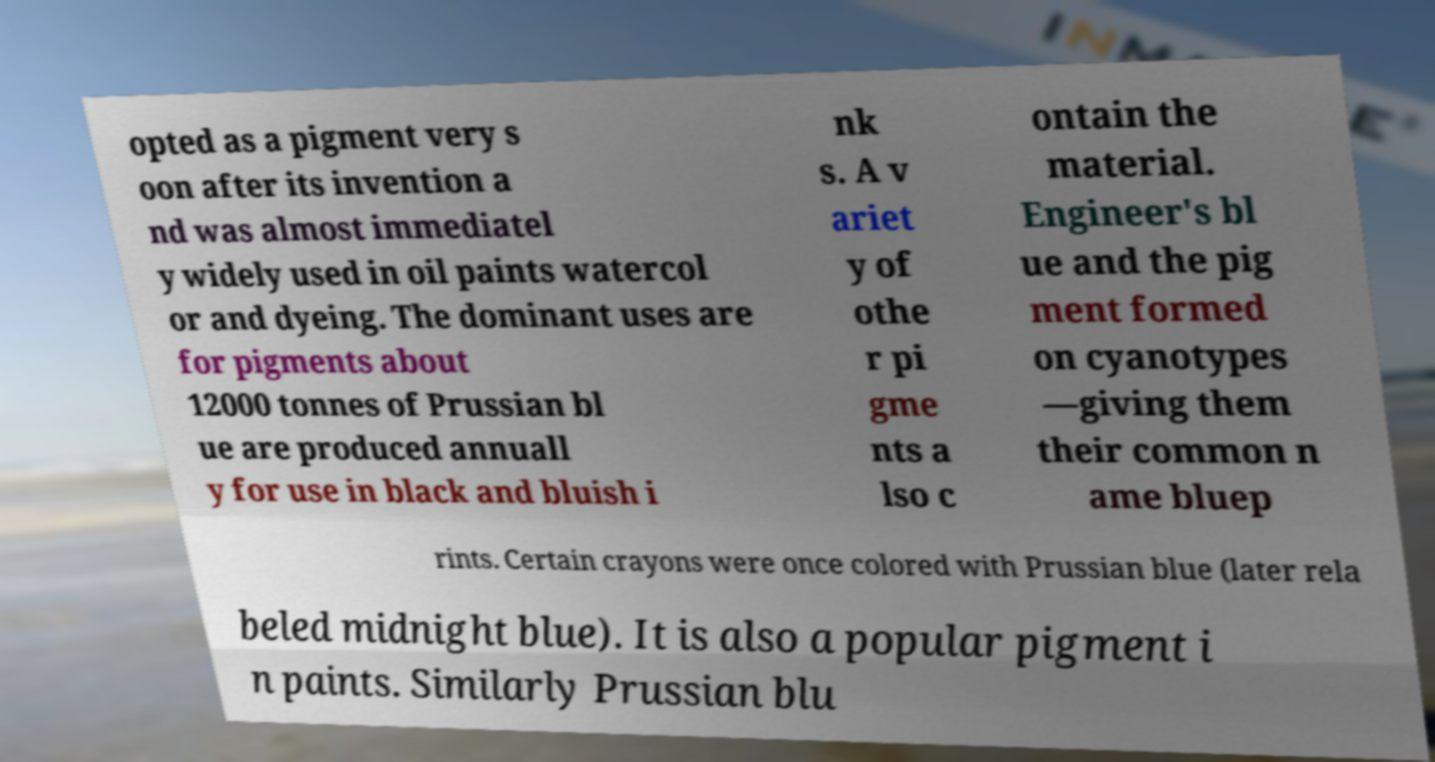Please read and relay the text visible in this image. What does it say? opted as a pigment very s oon after its invention a nd was almost immediatel y widely used in oil paints watercol or and dyeing. The dominant uses are for pigments about 12000 tonnes of Prussian bl ue are produced annuall y for use in black and bluish i nk s. A v ariet y of othe r pi gme nts a lso c ontain the material. Engineer's bl ue and the pig ment formed on cyanotypes —giving them their common n ame bluep rints. Certain crayons were once colored with Prussian blue (later rela beled midnight blue). It is also a popular pigment i n paints. Similarly Prussian blu 